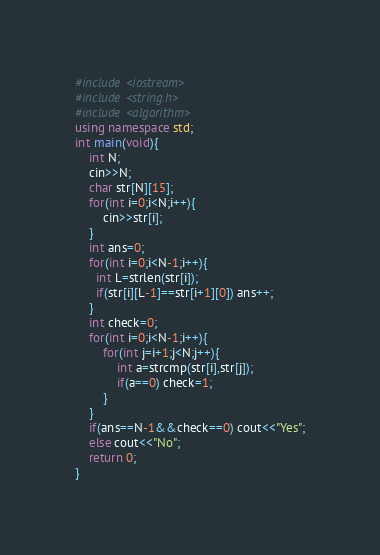Convert code to text. <code><loc_0><loc_0><loc_500><loc_500><_C++_>#include <iostream>
#include <string.h>
#include <algorithm>
using namespace std;
int main(void){
    int N;
    cin>>N;
    char str[N][15];
    for(int i=0;i<N;i++){
        cin>>str[i];
    }
    int ans=0;
    for(int i=0;i<N-1;i++){
      int L=strlen(str[i]);
      if(str[i][L-1]==str[i+1][0]) ans++;
    }
    int check=0;
    for(int i=0;i<N-1;i++){
        for(int j=i+1;j<N;j++){
            int a=strcmp(str[i],str[j]);
            if(a==0) check=1;
        }
    }
    if(ans==N-1&&check==0) cout<<"Yes";
    else cout<<"No";
    return 0;
}
</code> 